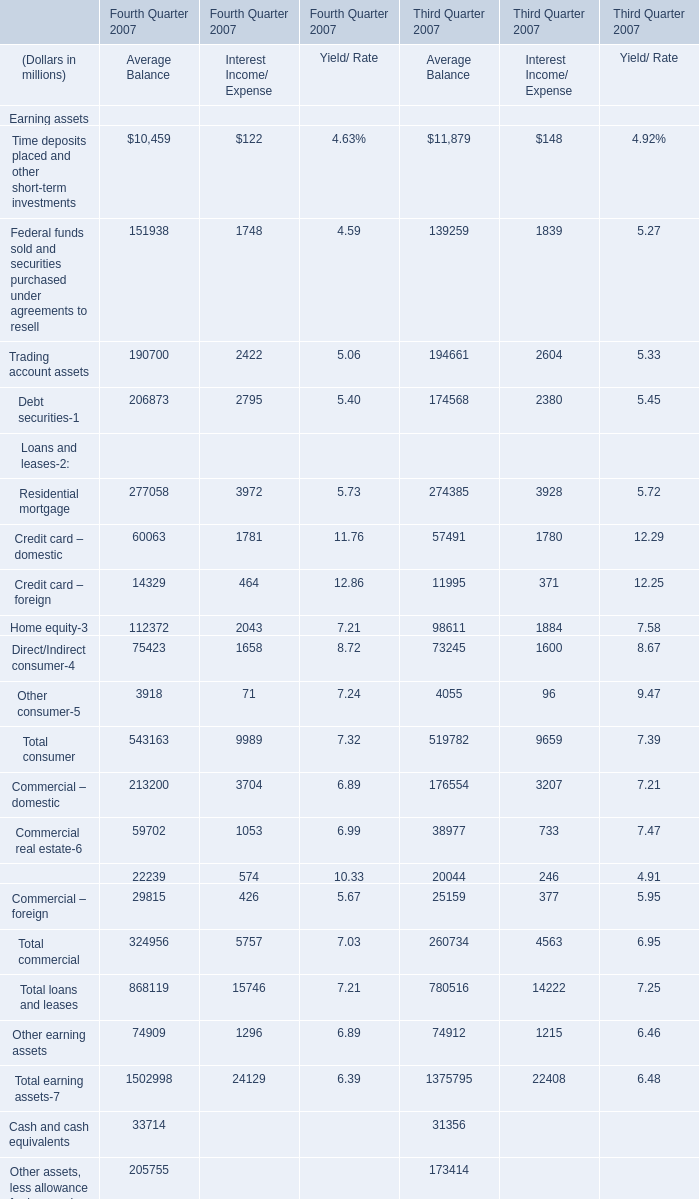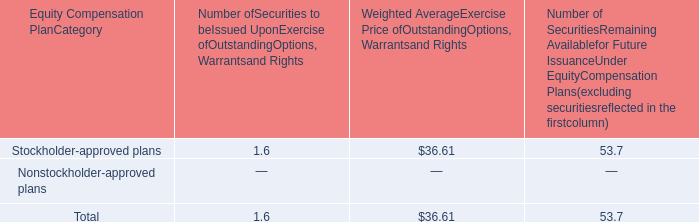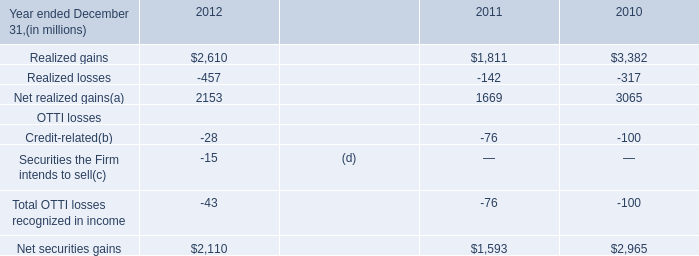What's the sum of Net securities gains OTTI losses of 2011, and Residential mortgage of Third Quarter 2007 Average Balance ? 
Computations: (1593.0 + 274385.0)
Answer: 275978.0. 